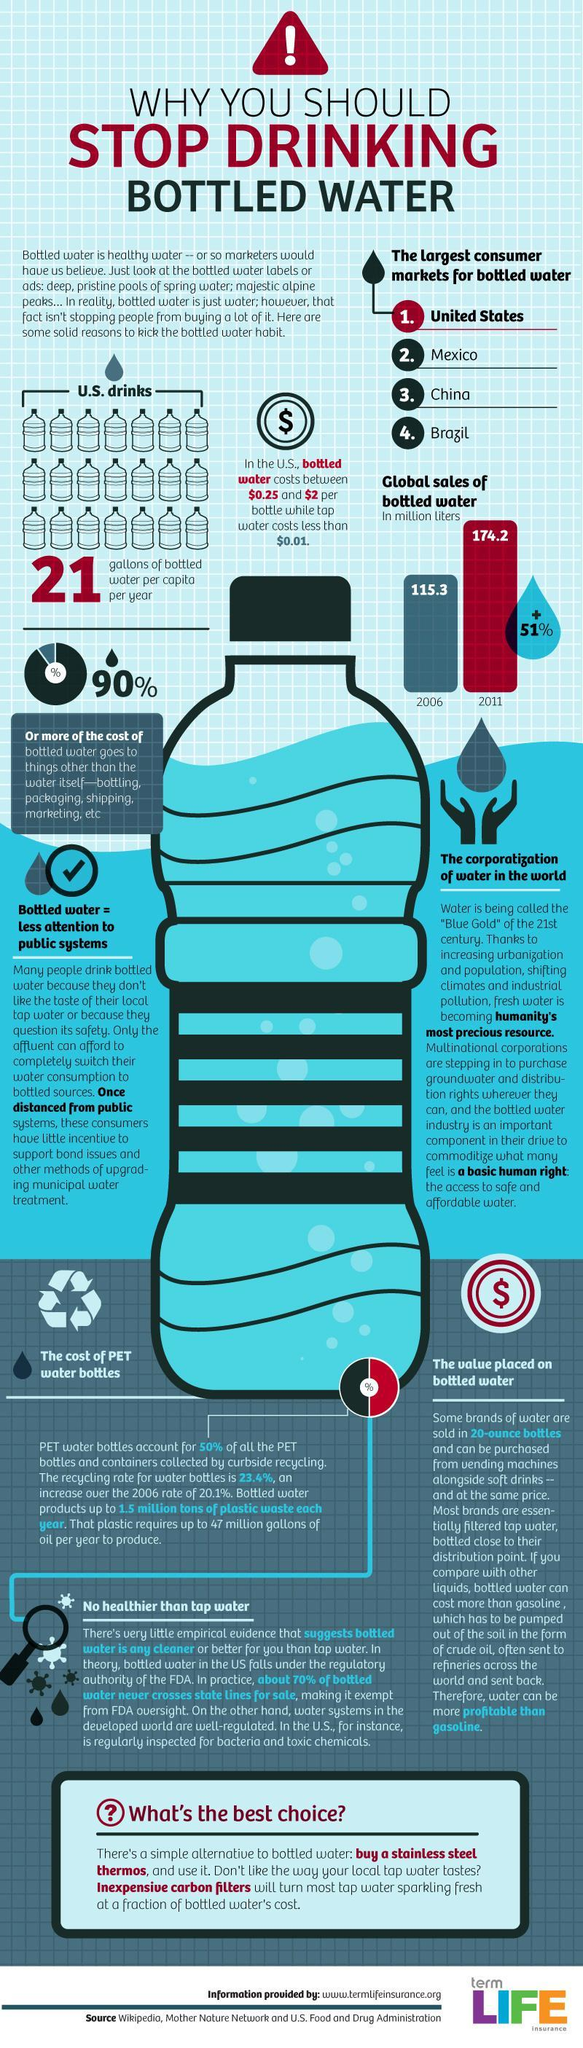How many sources are listed?
Answer the question with a short phrase. 3 By what amount did the global sales of bottled water increase from 2006 to 2011 in million liters? 58.9 million liters 